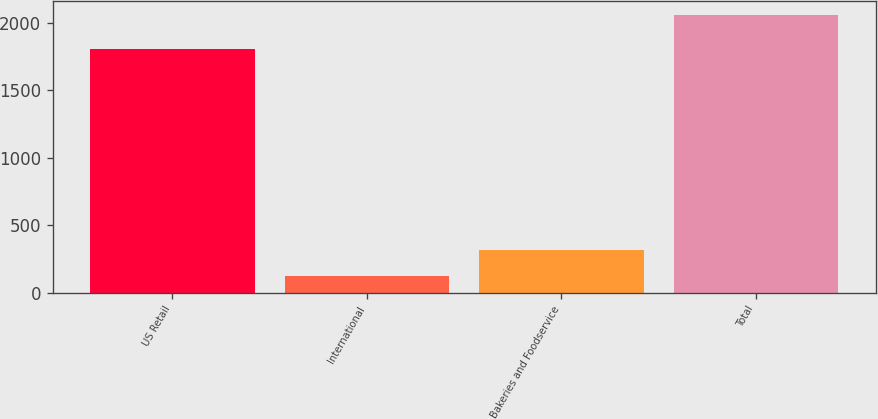Convert chart. <chart><loc_0><loc_0><loc_500><loc_500><bar_chart><fcel>US Retail<fcel>International<fcel>Bakeries and Foodservice<fcel>Total<nl><fcel>1809<fcel>119<fcel>313.1<fcel>2060<nl></chart> 